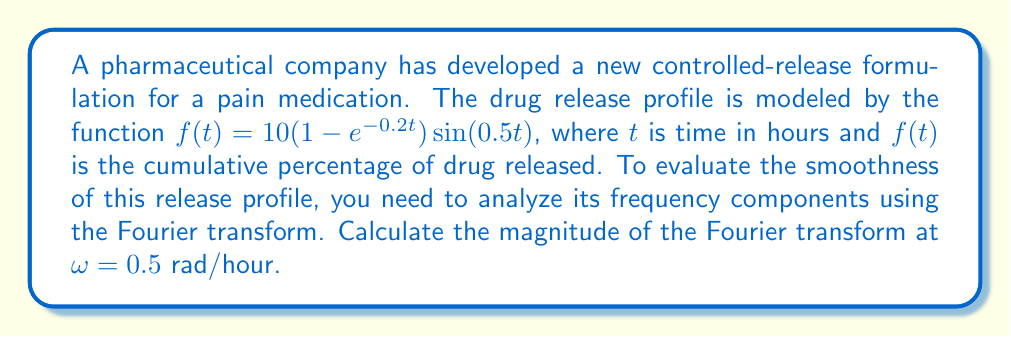Solve this math problem. To solve this problem, we need to follow these steps:

1) The Fourier transform of $f(t)$ is given by:

   $$F(\omega) = \int_{-\infty}^{\infty} f(t)e^{-i\omega t}dt$$

2) In our case, $f(t) = 10(1-e^{-0.2t})\sin(0.5t)$ for $t \geq 0$ and $f(t) = 0$ for $t < 0$. So we can write:

   $$F(\omega) = 10\int_{0}^{\infty} (1-e^{-0.2t})\sin(0.5t)e^{-i\omega t}dt$$

3) We can use the identity $\sin(0.5t) = \frac{e^{i0.5t} - e^{-i0.5t}}{2i}$ to rewrite this as:

   $$F(\omega) = \frac{5}{i}\int_{0}^{\infty} (1-e^{-0.2t})(e^{i0.5t} - e^{-i0.5t})e^{-i\omega t}dt$$

4) Expanding this:

   $$F(\omega) = \frac{5}{i}\int_{0}^{\infty} (e^{-i(\omega-0.5)t} - e^{-i(\omega+0.5)t} - e^{-0.2t}e^{-i(\omega-0.5)t} + e^{-0.2t}e^{-i(\omega+0.5)t})dt$$

5) Each term in this integral is of the form $\int_{0}^{\infty} e^{-at}dt = \frac{1}{a}$ for $Re(a) > 0$. Applying this:

   $$F(\omega) = \frac{5}{i}[\frac{1}{i(\omega-0.5)} - \frac{1}{i(\omega+0.5)} - \frac{1}{0.2+i(\omega-0.5)} + \frac{1}{0.2+i(\omega+0.5)}]$$

6) At $\omega = 0.5$, this becomes:

   $$F(0.5) = \frac{5}{i}[i - \frac{1}{i} - \frac{1}{0.2} + \frac{1}{0.2+i}]$$

7) Simplifying:

   $$F(0.5) = 5[1 + i - \frac{5}{1+i}] = 5[1 + i - \frac{5(1-i)}{2}] = 5 - \frac{25}{2} + i(5 - \frac{25}{2})$$

8) The magnitude of the Fourier transform is given by $|F(0.5)| = \sqrt{Re(F(0.5))^2 + Im(F(0.5))^2}$:

   $$|F(0.5)| = \sqrt{(5 - \frac{25}{2})^2 + (5 - \frac{25}{2})^2} = \sqrt{2(5 - \frac{25}{2})^2} = \sqrt{2}|5 - \frac{25}{2}| = \sqrt{2} \cdot \frac{15}{2}$$
Answer: The magnitude of the Fourier transform at $\omega = 0.5$ rad/hour is $\frac{15\sqrt{2}}{2} \approx 10.61$ units. 